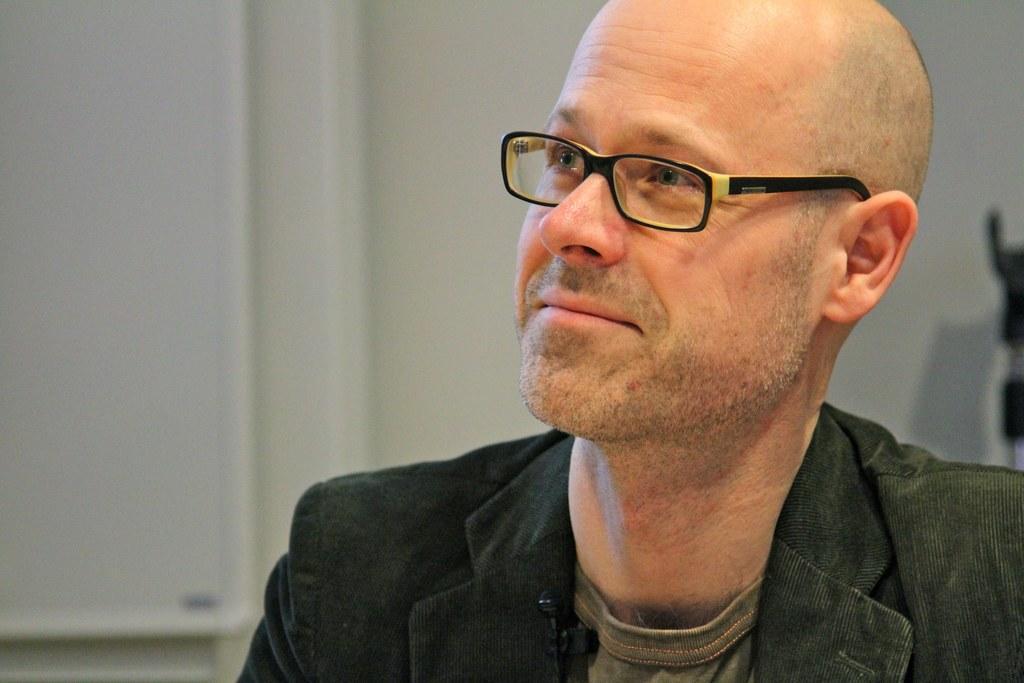In one or two sentences, can you explain what this image depicts? In the center of the image there is a person wearing spectacles. In the background there is wall. 